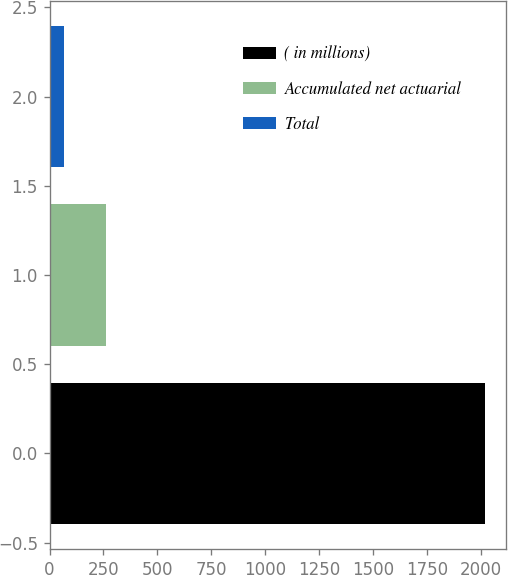Convert chart to OTSL. <chart><loc_0><loc_0><loc_500><loc_500><bar_chart><fcel>( in millions)<fcel>Accumulated net actuarial<fcel>Total<nl><fcel>2018<fcel>260.3<fcel>65<nl></chart> 